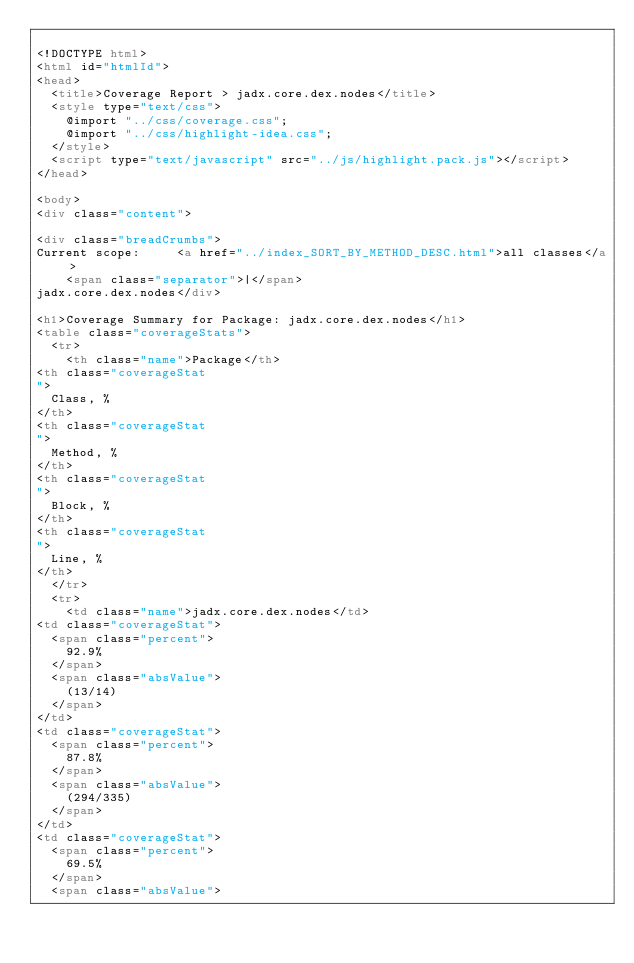Convert code to text. <code><loc_0><loc_0><loc_500><loc_500><_HTML_>
<!DOCTYPE html>
<html id="htmlId">
<head>
  <title>Coverage Report > jadx.core.dex.nodes</title>
  <style type="text/css">
    @import "../css/coverage.css";
    @import "../css/highlight-idea.css";
  </style>
  <script type="text/javascript" src="../js/highlight.pack.js"></script>
</head>

<body>
<div class="content">

<div class="breadCrumbs">
Current scope:     <a href="../index_SORT_BY_METHOD_DESC.html">all classes</a>
    <span class="separator">|</span>
jadx.core.dex.nodes</div>

<h1>Coverage Summary for Package: jadx.core.dex.nodes</h1>
<table class="coverageStats">
  <tr>
    <th class="name">Package</th>
<th class="coverageStat 
">
  Class, %
</th>
<th class="coverageStat 
">
  Method, %
</th>
<th class="coverageStat 
">
  Block, %
</th>
<th class="coverageStat 
">
  Line, %
</th>
  </tr>
  <tr>
    <td class="name">jadx.core.dex.nodes</td>
<td class="coverageStat">
  <span class="percent">
    92.9%
  </span>
  <span class="absValue">
    (13/14)
  </span>
</td>
<td class="coverageStat">
  <span class="percent">
    87.8%
  </span>
  <span class="absValue">
    (294/335)
  </span>
</td>
<td class="coverageStat">
  <span class="percent">
    69.5%
  </span>
  <span class="absValue"></code> 